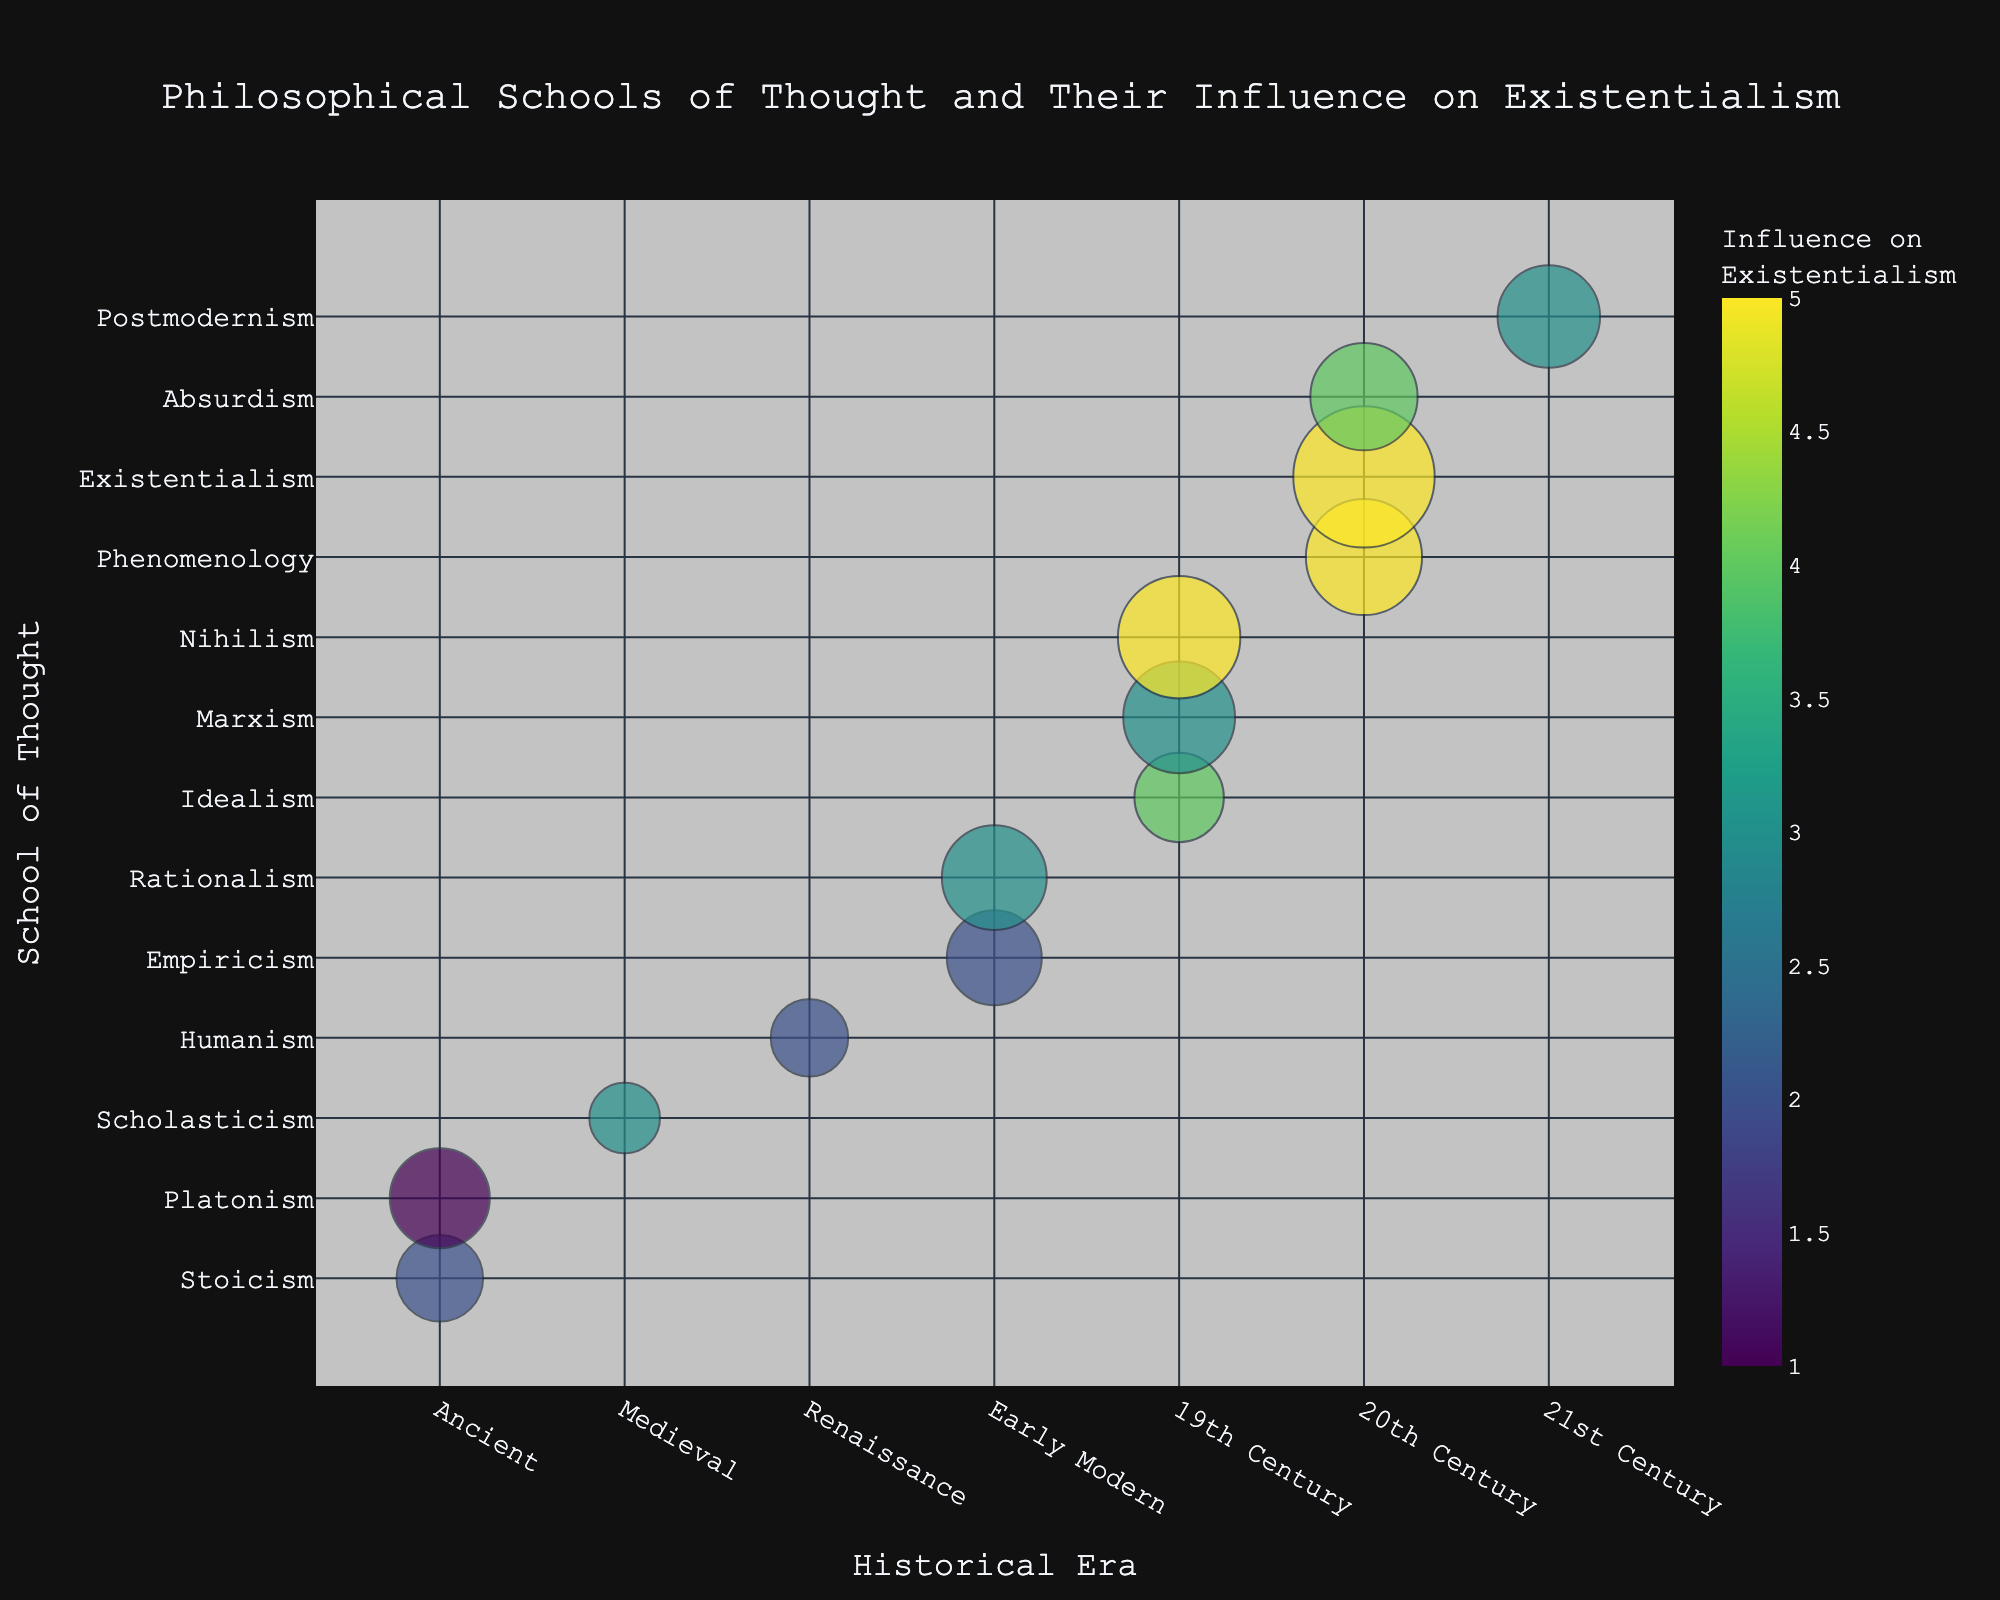What is the era with the highest influence on existentialism based on the bubble chart? The era with the bubble that reaches the maximum color intensity represents the highest influence on existentialism. In the chart, this appears to be the "20th Century" with a color value corresponding to the highest influence.
Answer: 20th Century Which philosopher from the 21st Century is highlighted in the chart? The bubble corresponding to the 21st Century mentions "Michel Foucault" as the major philosopher.
Answer: Michel Foucault Compare the number of publications by Jean-Paul Sartre and Friedrich Nietzsche. Who has more? Look for the sizes of the bubbles for Jean-Paul Sartre and Friedrich Nietzsche. Sartre's bubble is larger with a count of 40 publications compared to Nietzsche's 30 publications.
Answer: Jean-Paul Sartre Among all the schools of thought listed, which one has the least influence on existentialism, and who is the associated philosopher? By observing the color scale intensity, the school with the least influence has the least intense color. The chart indicates "Platonism" with Philosopher "Plato" having an influence value of 1.
Answer: Platonism, Plato What is the range of the influence on existentialism depicted in the chart? Observing the color scale, the influence values range from the lowest, which is 1, to the highest being 5.
Answer: 1 to 5 Which schools of thought have an influence value of 4 on existentialism, and which eras do they belong to? By checking the bubbles with the corresponding color for an influence value of 4, "Idealism" in the 19th Century and "Absurdism" in the 20th Century fit this criterion.
Answer: Idealism (19th Century), Absurdism (20th Century) What are the counts of publications for major philosophers in the Early Modern era? Check the two bubbles in the Early Modern era, "Empiricism" has 18 publications, and "Rationalism" has 22 publications.
Answer: Empiricism: 18, Rationalism: 22 How does the size of the bubble representing Seneca's publications compare to that of Michel Foucault's? The size of the bubble for "Seneca" is smaller with 15 publications compared to "Michel Foucault," which is 21 publications.
Answer: Michel Foucault's is larger Which philosophical school from the 19th Century has the highest influence on existentialism, and how many publications are associated with it? Within the 19th Century bubbles, "Nihilism" with Friedrich Nietzsche has the highest influence on existentialism (value 5) and has 30 publications.
Answer: Nihilism, 30 Which school of thought has more publications: Humanism in the Renaissance or Phenomenology in the 20th Century? Compare the sizes of the bubbles for Humanism and Phenomenology. Humanism has 12 publications, whereas Phenomenology has 27 publications.
Answer: Phenomenology in the 20th Century 